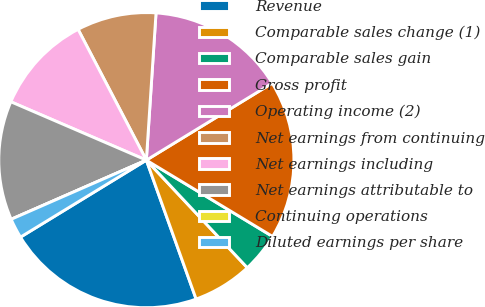<chart> <loc_0><loc_0><loc_500><loc_500><pie_chart><fcel>Revenue<fcel>Comparable sales change (1)<fcel>Comparable sales gain<fcel>Gross profit<fcel>Operating income (2)<fcel>Net earnings from continuing<fcel>Net earnings including<fcel>Net earnings attributable to<fcel>Continuing operations<fcel>Diluted earnings per share<nl><fcel>21.74%<fcel>6.52%<fcel>4.35%<fcel>17.39%<fcel>15.22%<fcel>8.7%<fcel>10.87%<fcel>13.04%<fcel>0.0%<fcel>2.17%<nl></chart> 